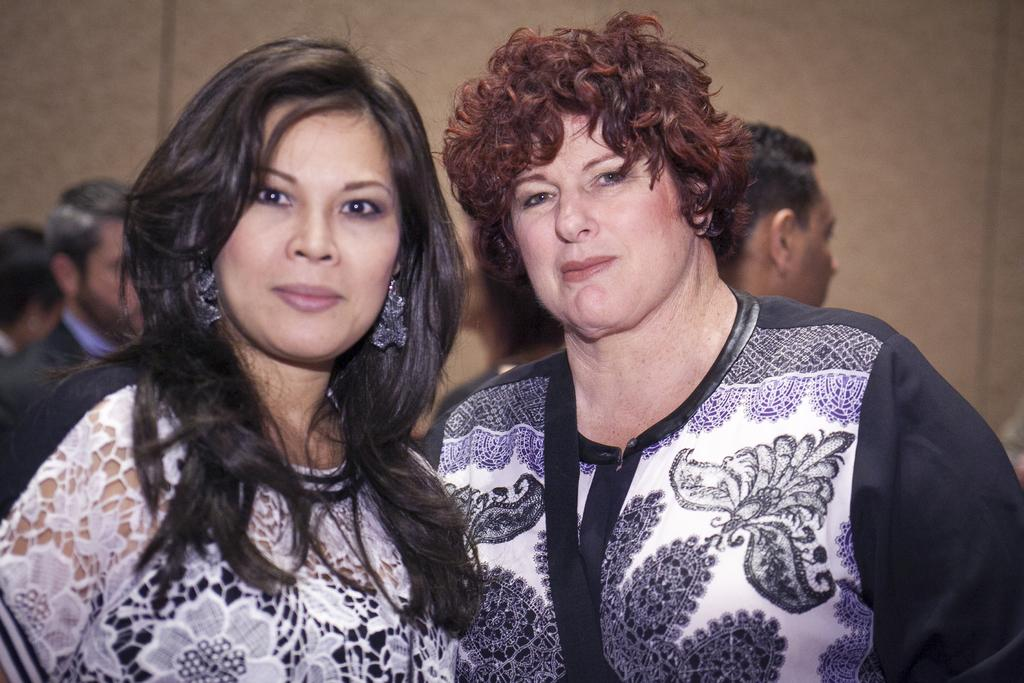What can be seen in the image? There are people in the image. What is the color of the background in the image? The background color of the image is brown. Are there any dinosaurs visible in the image? No, there are no dinosaurs present in the image. 